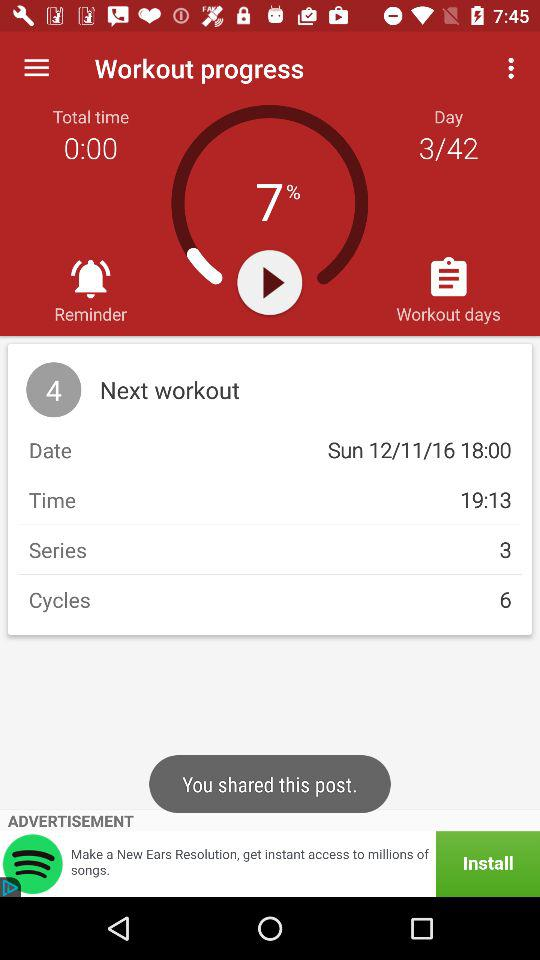What is the progress of the workout? The progress of the workout is 7%. 